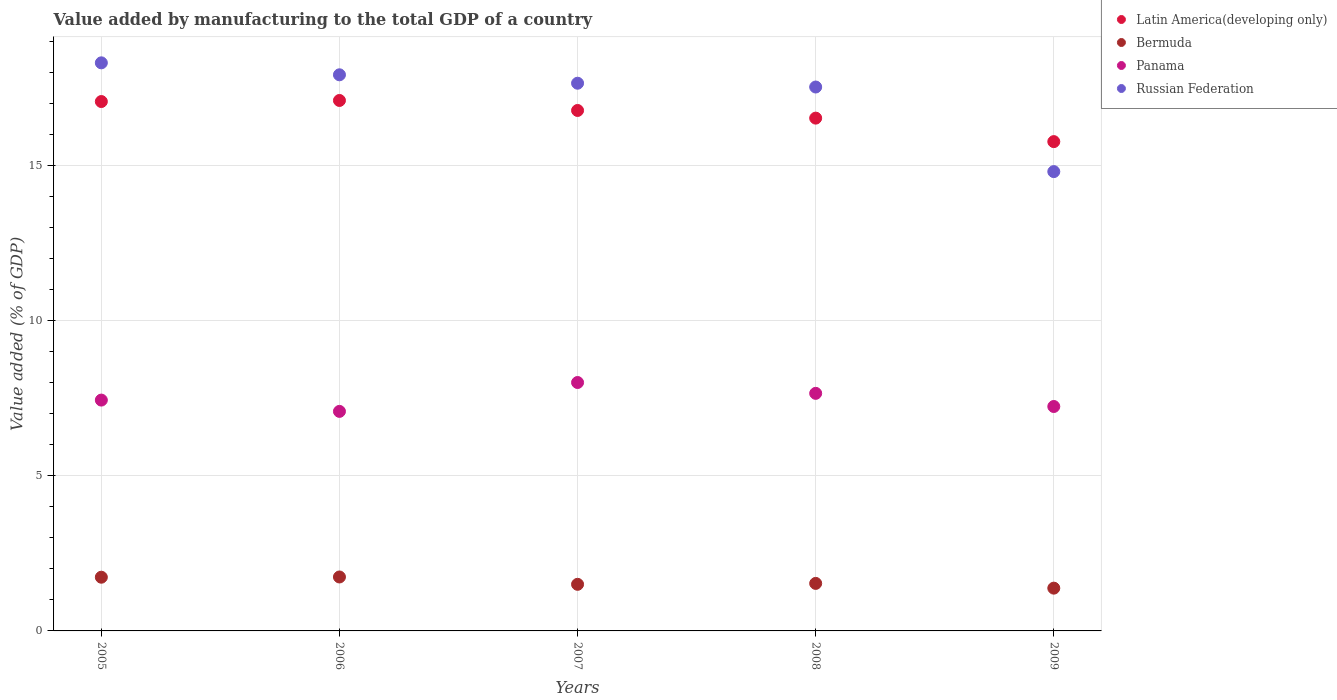Is the number of dotlines equal to the number of legend labels?
Keep it short and to the point. Yes. What is the value added by manufacturing to the total GDP in Latin America(developing only) in 2008?
Keep it short and to the point. 16.52. Across all years, what is the maximum value added by manufacturing to the total GDP in Panama?
Make the answer very short. 8. Across all years, what is the minimum value added by manufacturing to the total GDP in Panama?
Give a very brief answer. 7.07. In which year was the value added by manufacturing to the total GDP in Latin America(developing only) maximum?
Make the answer very short. 2006. In which year was the value added by manufacturing to the total GDP in Panama minimum?
Make the answer very short. 2006. What is the total value added by manufacturing to the total GDP in Panama in the graph?
Keep it short and to the point. 37.39. What is the difference between the value added by manufacturing to the total GDP in Bermuda in 2006 and that in 2008?
Your answer should be very brief. 0.21. What is the difference between the value added by manufacturing to the total GDP in Latin America(developing only) in 2005 and the value added by manufacturing to the total GDP in Russian Federation in 2009?
Ensure brevity in your answer.  2.26. What is the average value added by manufacturing to the total GDP in Latin America(developing only) per year?
Provide a short and direct response. 16.64. In the year 2005, what is the difference between the value added by manufacturing to the total GDP in Panama and value added by manufacturing to the total GDP in Latin America(developing only)?
Make the answer very short. -9.62. What is the ratio of the value added by manufacturing to the total GDP in Latin America(developing only) in 2006 to that in 2007?
Offer a very short reply. 1.02. What is the difference between the highest and the second highest value added by manufacturing to the total GDP in Panama?
Your answer should be very brief. 0.35. What is the difference between the highest and the lowest value added by manufacturing to the total GDP in Panama?
Ensure brevity in your answer.  0.93. Is it the case that in every year, the sum of the value added by manufacturing to the total GDP in Panama and value added by manufacturing to the total GDP in Latin America(developing only)  is greater than the sum of value added by manufacturing to the total GDP in Russian Federation and value added by manufacturing to the total GDP in Bermuda?
Your response must be concise. No. Does the value added by manufacturing to the total GDP in Latin America(developing only) monotonically increase over the years?
Your answer should be compact. No. What is the title of the graph?
Provide a succinct answer. Value added by manufacturing to the total GDP of a country. What is the label or title of the Y-axis?
Ensure brevity in your answer.  Value added (% of GDP). What is the Value added (% of GDP) of Latin America(developing only) in 2005?
Offer a terse response. 17.05. What is the Value added (% of GDP) of Bermuda in 2005?
Your answer should be compact. 1.73. What is the Value added (% of GDP) of Panama in 2005?
Your response must be concise. 7.44. What is the Value added (% of GDP) in Russian Federation in 2005?
Provide a short and direct response. 18.3. What is the Value added (% of GDP) in Latin America(developing only) in 2006?
Your response must be concise. 17.09. What is the Value added (% of GDP) in Bermuda in 2006?
Your answer should be very brief. 1.74. What is the Value added (% of GDP) in Panama in 2006?
Offer a very short reply. 7.07. What is the Value added (% of GDP) in Russian Federation in 2006?
Provide a short and direct response. 17.91. What is the Value added (% of GDP) of Latin America(developing only) in 2007?
Make the answer very short. 16.76. What is the Value added (% of GDP) in Bermuda in 2007?
Give a very brief answer. 1.5. What is the Value added (% of GDP) of Panama in 2007?
Ensure brevity in your answer.  8. What is the Value added (% of GDP) of Russian Federation in 2007?
Give a very brief answer. 17.64. What is the Value added (% of GDP) of Latin America(developing only) in 2008?
Your response must be concise. 16.52. What is the Value added (% of GDP) in Bermuda in 2008?
Give a very brief answer. 1.53. What is the Value added (% of GDP) of Panama in 2008?
Ensure brevity in your answer.  7.65. What is the Value added (% of GDP) of Russian Federation in 2008?
Provide a short and direct response. 17.52. What is the Value added (% of GDP) in Latin America(developing only) in 2009?
Provide a short and direct response. 15.76. What is the Value added (% of GDP) in Bermuda in 2009?
Your answer should be compact. 1.38. What is the Value added (% of GDP) of Panama in 2009?
Make the answer very short. 7.23. What is the Value added (% of GDP) of Russian Federation in 2009?
Provide a succinct answer. 14.79. Across all years, what is the maximum Value added (% of GDP) of Latin America(developing only)?
Your response must be concise. 17.09. Across all years, what is the maximum Value added (% of GDP) of Bermuda?
Your answer should be compact. 1.74. Across all years, what is the maximum Value added (% of GDP) in Panama?
Provide a succinct answer. 8. Across all years, what is the maximum Value added (% of GDP) of Russian Federation?
Your response must be concise. 18.3. Across all years, what is the minimum Value added (% of GDP) of Latin America(developing only)?
Offer a terse response. 15.76. Across all years, what is the minimum Value added (% of GDP) of Bermuda?
Keep it short and to the point. 1.38. Across all years, what is the minimum Value added (% of GDP) of Panama?
Your answer should be compact. 7.07. Across all years, what is the minimum Value added (% of GDP) in Russian Federation?
Your answer should be very brief. 14.79. What is the total Value added (% of GDP) of Latin America(developing only) in the graph?
Make the answer very short. 83.18. What is the total Value added (% of GDP) of Bermuda in the graph?
Your answer should be very brief. 7.88. What is the total Value added (% of GDP) of Panama in the graph?
Your response must be concise. 37.39. What is the total Value added (% of GDP) of Russian Federation in the graph?
Provide a short and direct response. 86.17. What is the difference between the Value added (% of GDP) of Latin America(developing only) in 2005 and that in 2006?
Offer a very short reply. -0.03. What is the difference between the Value added (% of GDP) in Bermuda in 2005 and that in 2006?
Provide a succinct answer. -0.01. What is the difference between the Value added (% of GDP) of Panama in 2005 and that in 2006?
Your response must be concise. 0.36. What is the difference between the Value added (% of GDP) of Russian Federation in 2005 and that in 2006?
Provide a succinct answer. 0.39. What is the difference between the Value added (% of GDP) of Latin America(developing only) in 2005 and that in 2007?
Your answer should be very brief. 0.29. What is the difference between the Value added (% of GDP) in Bermuda in 2005 and that in 2007?
Offer a terse response. 0.23. What is the difference between the Value added (% of GDP) of Panama in 2005 and that in 2007?
Keep it short and to the point. -0.57. What is the difference between the Value added (% of GDP) of Russian Federation in 2005 and that in 2007?
Ensure brevity in your answer.  0.66. What is the difference between the Value added (% of GDP) of Latin America(developing only) in 2005 and that in 2008?
Offer a very short reply. 0.53. What is the difference between the Value added (% of GDP) of Bermuda in 2005 and that in 2008?
Your response must be concise. 0.2. What is the difference between the Value added (% of GDP) in Panama in 2005 and that in 2008?
Provide a short and direct response. -0.22. What is the difference between the Value added (% of GDP) of Russian Federation in 2005 and that in 2008?
Offer a very short reply. 0.78. What is the difference between the Value added (% of GDP) of Latin America(developing only) in 2005 and that in 2009?
Offer a terse response. 1.29. What is the difference between the Value added (% of GDP) of Bermuda in 2005 and that in 2009?
Your answer should be compact. 0.35. What is the difference between the Value added (% of GDP) of Panama in 2005 and that in 2009?
Ensure brevity in your answer.  0.21. What is the difference between the Value added (% of GDP) in Russian Federation in 2005 and that in 2009?
Your response must be concise. 3.5. What is the difference between the Value added (% of GDP) of Latin America(developing only) in 2006 and that in 2007?
Your answer should be compact. 0.32. What is the difference between the Value added (% of GDP) of Bermuda in 2006 and that in 2007?
Give a very brief answer. 0.24. What is the difference between the Value added (% of GDP) of Panama in 2006 and that in 2007?
Give a very brief answer. -0.93. What is the difference between the Value added (% of GDP) in Russian Federation in 2006 and that in 2007?
Your response must be concise. 0.27. What is the difference between the Value added (% of GDP) of Latin America(developing only) in 2006 and that in 2008?
Keep it short and to the point. 0.57. What is the difference between the Value added (% of GDP) in Bermuda in 2006 and that in 2008?
Offer a very short reply. 0.21. What is the difference between the Value added (% of GDP) of Panama in 2006 and that in 2008?
Your answer should be very brief. -0.58. What is the difference between the Value added (% of GDP) in Russian Federation in 2006 and that in 2008?
Offer a terse response. 0.39. What is the difference between the Value added (% of GDP) in Latin America(developing only) in 2006 and that in 2009?
Keep it short and to the point. 1.33. What is the difference between the Value added (% of GDP) of Bermuda in 2006 and that in 2009?
Make the answer very short. 0.36. What is the difference between the Value added (% of GDP) of Panama in 2006 and that in 2009?
Keep it short and to the point. -0.16. What is the difference between the Value added (% of GDP) in Russian Federation in 2006 and that in 2009?
Ensure brevity in your answer.  3.12. What is the difference between the Value added (% of GDP) in Latin America(developing only) in 2007 and that in 2008?
Provide a short and direct response. 0.25. What is the difference between the Value added (% of GDP) in Bermuda in 2007 and that in 2008?
Provide a short and direct response. -0.03. What is the difference between the Value added (% of GDP) of Panama in 2007 and that in 2008?
Keep it short and to the point. 0.35. What is the difference between the Value added (% of GDP) of Russian Federation in 2007 and that in 2008?
Provide a succinct answer. 0.12. What is the difference between the Value added (% of GDP) of Latin America(developing only) in 2007 and that in 2009?
Your answer should be compact. 1. What is the difference between the Value added (% of GDP) in Bermuda in 2007 and that in 2009?
Your response must be concise. 0.12. What is the difference between the Value added (% of GDP) in Panama in 2007 and that in 2009?
Provide a succinct answer. 0.77. What is the difference between the Value added (% of GDP) in Russian Federation in 2007 and that in 2009?
Ensure brevity in your answer.  2.85. What is the difference between the Value added (% of GDP) of Latin America(developing only) in 2008 and that in 2009?
Give a very brief answer. 0.76. What is the difference between the Value added (% of GDP) in Bermuda in 2008 and that in 2009?
Keep it short and to the point. 0.15. What is the difference between the Value added (% of GDP) of Panama in 2008 and that in 2009?
Make the answer very short. 0.42. What is the difference between the Value added (% of GDP) in Russian Federation in 2008 and that in 2009?
Give a very brief answer. 2.72. What is the difference between the Value added (% of GDP) of Latin America(developing only) in 2005 and the Value added (% of GDP) of Bermuda in 2006?
Give a very brief answer. 15.31. What is the difference between the Value added (% of GDP) in Latin America(developing only) in 2005 and the Value added (% of GDP) in Panama in 2006?
Your response must be concise. 9.98. What is the difference between the Value added (% of GDP) of Latin America(developing only) in 2005 and the Value added (% of GDP) of Russian Federation in 2006?
Your response must be concise. -0.86. What is the difference between the Value added (% of GDP) of Bermuda in 2005 and the Value added (% of GDP) of Panama in 2006?
Offer a terse response. -5.34. What is the difference between the Value added (% of GDP) of Bermuda in 2005 and the Value added (% of GDP) of Russian Federation in 2006?
Make the answer very short. -16.18. What is the difference between the Value added (% of GDP) of Panama in 2005 and the Value added (% of GDP) of Russian Federation in 2006?
Make the answer very short. -10.48. What is the difference between the Value added (% of GDP) in Latin America(developing only) in 2005 and the Value added (% of GDP) in Bermuda in 2007?
Offer a terse response. 15.55. What is the difference between the Value added (% of GDP) in Latin America(developing only) in 2005 and the Value added (% of GDP) in Panama in 2007?
Offer a very short reply. 9.05. What is the difference between the Value added (% of GDP) in Latin America(developing only) in 2005 and the Value added (% of GDP) in Russian Federation in 2007?
Offer a very short reply. -0.59. What is the difference between the Value added (% of GDP) in Bermuda in 2005 and the Value added (% of GDP) in Panama in 2007?
Your response must be concise. -6.27. What is the difference between the Value added (% of GDP) of Bermuda in 2005 and the Value added (% of GDP) of Russian Federation in 2007?
Give a very brief answer. -15.91. What is the difference between the Value added (% of GDP) of Panama in 2005 and the Value added (% of GDP) of Russian Federation in 2007?
Give a very brief answer. -10.21. What is the difference between the Value added (% of GDP) in Latin America(developing only) in 2005 and the Value added (% of GDP) in Bermuda in 2008?
Keep it short and to the point. 15.52. What is the difference between the Value added (% of GDP) of Latin America(developing only) in 2005 and the Value added (% of GDP) of Panama in 2008?
Make the answer very short. 9.4. What is the difference between the Value added (% of GDP) in Latin America(developing only) in 2005 and the Value added (% of GDP) in Russian Federation in 2008?
Offer a terse response. -0.47. What is the difference between the Value added (% of GDP) of Bermuda in 2005 and the Value added (% of GDP) of Panama in 2008?
Make the answer very short. -5.92. What is the difference between the Value added (% of GDP) of Bermuda in 2005 and the Value added (% of GDP) of Russian Federation in 2008?
Keep it short and to the point. -15.79. What is the difference between the Value added (% of GDP) in Panama in 2005 and the Value added (% of GDP) in Russian Federation in 2008?
Provide a succinct answer. -10.08. What is the difference between the Value added (% of GDP) in Latin America(developing only) in 2005 and the Value added (% of GDP) in Bermuda in 2009?
Your answer should be compact. 15.67. What is the difference between the Value added (% of GDP) of Latin America(developing only) in 2005 and the Value added (% of GDP) of Panama in 2009?
Offer a terse response. 9.82. What is the difference between the Value added (% of GDP) in Latin America(developing only) in 2005 and the Value added (% of GDP) in Russian Federation in 2009?
Give a very brief answer. 2.26. What is the difference between the Value added (% of GDP) of Bermuda in 2005 and the Value added (% of GDP) of Panama in 2009?
Your answer should be very brief. -5.5. What is the difference between the Value added (% of GDP) in Bermuda in 2005 and the Value added (% of GDP) in Russian Federation in 2009?
Give a very brief answer. -13.07. What is the difference between the Value added (% of GDP) of Panama in 2005 and the Value added (% of GDP) of Russian Federation in 2009?
Give a very brief answer. -7.36. What is the difference between the Value added (% of GDP) in Latin America(developing only) in 2006 and the Value added (% of GDP) in Bermuda in 2007?
Ensure brevity in your answer.  15.59. What is the difference between the Value added (% of GDP) of Latin America(developing only) in 2006 and the Value added (% of GDP) of Panama in 2007?
Ensure brevity in your answer.  9.08. What is the difference between the Value added (% of GDP) in Latin America(developing only) in 2006 and the Value added (% of GDP) in Russian Federation in 2007?
Your answer should be compact. -0.56. What is the difference between the Value added (% of GDP) in Bermuda in 2006 and the Value added (% of GDP) in Panama in 2007?
Make the answer very short. -6.26. What is the difference between the Value added (% of GDP) of Bermuda in 2006 and the Value added (% of GDP) of Russian Federation in 2007?
Offer a terse response. -15.9. What is the difference between the Value added (% of GDP) in Panama in 2006 and the Value added (% of GDP) in Russian Federation in 2007?
Provide a succinct answer. -10.57. What is the difference between the Value added (% of GDP) in Latin America(developing only) in 2006 and the Value added (% of GDP) in Bermuda in 2008?
Offer a terse response. 15.56. What is the difference between the Value added (% of GDP) of Latin America(developing only) in 2006 and the Value added (% of GDP) of Panama in 2008?
Your answer should be very brief. 9.43. What is the difference between the Value added (% of GDP) in Latin America(developing only) in 2006 and the Value added (% of GDP) in Russian Federation in 2008?
Make the answer very short. -0.43. What is the difference between the Value added (% of GDP) in Bermuda in 2006 and the Value added (% of GDP) in Panama in 2008?
Offer a very short reply. -5.91. What is the difference between the Value added (% of GDP) in Bermuda in 2006 and the Value added (% of GDP) in Russian Federation in 2008?
Ensure brevity in your answer.  -15.78. What is the difference between the Value added (% of GDP) of Panama in 2006 and the Value added (% of GDP) of Russian Federation in 2008?
Offer a very short reply. -10.45. What is the difference between the Value added (% of GDP) in Latin America(developing only) in 2006 and the Value added (% of GDP) in Bermuda in 2009?
Your response must be concise. 15.71. What is the difference between the Value added (% of GDP) in Latin America(developing only) in 2006 and the Value added (% of GDP) in Panama in 2009?
Your response must be concise. 9.86. What is the difference between the Value added (% of GDP) in Latin America(developing only) in 2006 and the Value added (% of GDP) in Russian Federation in 2009?
Offer a terse response. 2.29. What is the difference between the Value added (% of GDP) of Bermuda in 2006 and the Value added (% of GDP) of Panama in 2009?
Provide a succinct answer. -5.49. What is the difference between the Value added (% of GDP) in Bermuda in 2006 and the Value added (% of GDP) in Russian Federation in 2009?
Give a very brief answer. -13.06. What is the difference between the Value added (% of GDP) of Panama in 2006 and the Value added (% of GDP) of Russian Federation in 2009?
Ensure brevity in your answer.  -7.72. What is the difference between the Value added (% of GDP) in Latin America(developing only) in 2007 and the Value added (% of GDP) in Bermuda in 2008?
Give a very brief answer. 15.23. What is the difference between the Value added (% of GDP) in Latin America(developing only) in 2007 and the Value added (% of GDP) in Panama in 2008?
Offer a terse response. 9.11. What is the difference between the Value added (% of GDP) in Latin America(developing only) in 2007 and the Value added (% of GDP) in Russian Federation in 2008?
Your response must be concise. -0.76. What is the difference between the Value added (% of GDP) of Bermuda in 2007 and the Value added (% of GDP) of Panama in 2008?
Your response must be concise. -6.15. What is the difference between the Value added (% of GDP) of Bermuda in 2007 and the Value added (% of GDP) of Russian Federation in 2008?
Ensure brevity in your answer.  -16.02. What is the difference between the Value added (% of GDP) of Panama in 2007 and the Value added (% of GDP) of Russian Federation in 2008?
Your answer should be compact. -9.52. What is the difference between the Value added (% of GDP) of Latin America(developing only) in 2007 and the Value added (% of GDP) of Bermuda in 2009?
Your response must be concise. 15.39. What is the difference between the Value added (% of GDP) in Latin America(developing only) in 2007 and the Value added (% of GDP) in Panama in 2009?
Provide a short and direct response. 9.54. What is the difference between the Value added (% of GDP) in Latin America(developing only) in 2007 and the Value added (% of GDP) in Russian Federation in 2009?
Provide a short and direct response. 1.97. What is the difference between the Value added (% of GDP) of Bermuda in 2007 and the Value added (% of GDP) of Panama in 2009?
Your answer should be very brief. -5.73. What is the difference between the Value added (% of GDP) in Bermuda in 2007 and the Value added (% of GDP) in Russian Federation in 2009?
Provide a short and direct response. -13.29. What is the difference between the Value added (% of GDP) in Panama in 2007 and the Value added (% of GDP) in Russian Federation in 2009?
Keep it short and to the point. -6.79. What is the difference between the Value added (% of GDP) of Latin America(developing only) in 2008 and the Value added (% of GDP) of Bermuda in 2009?
Your answer should be compact. 15.14. What is the difference between the Value added (% of GDP) of Latin America(developing only) in 2008 and the Value added (% of GDP) of Panama in 2009?
Your response must be concise. 9.29. What is the difference between the Value added (% of GDP) of Latin America(developing only) in 2008 and the Value added (% of GDP) of Russian Federation in 2009?
Ensure brevity in your answer.  1.72. What is the difference between the Value added (% of GDP) in Bermuda in 2008 and the Value added (% of GDP) in Panama in 2009?
Ensure brevity in your answer.  -5.7. What is the difference between the Value added (% of GDP) in Bermuda in 2008 and the Value added (% of GDP) in Russian Federation in 2009?
Your response must be concise. -13.26. What is the difference between the Value added (% of GDP) of Panama in 2008 and the Value added (% of GDP) of Russian Federation in 2009?
Your answer should be very brief. -7.14. What is the average Value added (% of GDP) of Latin America(developing only) per year?
Give a very brief answer. 16.64. What is the average Value added (% of GDP) in Bermuda per year?
Your answer should be compact. 1.58. What is the average Value added (% of GDP) of Panama per year?
Keep it short and to the point. 7.48. What is the average Value added (% of GDP) in Russian Federation per year?
Offer a very short reply. 17.23. In the year 2005, what is the difference between the Value added (% of GDP) of Latin America(developing only) and Value added (% of GDP) of Bermuda?
Offer a terse response. 15.32. In the year 2005, what is the difference between the Value added (% of GDP) in Latin America(developing only) and Value added (% of GDP) in Panama?
Ensure brevity in your answer.  9.62. In the year 2005, what is the difference between the Value added (% of GDP) of Latin America(developing only) and Value added (% of GDP) of Russian Federation?
Offer a terse response. -1.25. In the year 2005, what is the difference between the Value added (% of GDP) of Bermuda and Value added (% of GDP) of Panama?
Ensure brevity in your answer.  -5.71. In the year 2005, what is the difference between the Value added (% of GDP) in Bermuda and Value added (% of GDP) in Russian Federation?
Make the answer very short. -16.57. In the year 2005, what is the difference between the Value added (% of GDP) of Panama and Value added (% of GDP) of Russian Federation?
Keep it short and to the point. -10.86. In the year 2006, what is the difference between the Value added (% of GDP) of Latin America(developing only) and Value added (% of GDP) of Bermuda?
Give a very brief answer. 15.35. In the year 2006, what is the difference between the Value added (% of GDP) of Latin America(developing only) and Value added (% of GDP) of Panama?
Provide a short and direct response. 10.01. In the year 2006, what is the difference between the Value added (% of GDP) of Latin America(developing only) and Value added (% of GDP) of Russian Federation?
Provide a short and direct response. -0.83. In the year 2006, what is the difference between the Value added (% of GDP) of Bermuda and Value added (% of GDP) of Panama?
Give a very brief answer. -5.33. In the year 2006, what is the difference between the Value added (% of GDP) in Bermuda and Value added (% of GDP) in Russian Federation?
Provide a succinct answer. -16.18. In the year 2006, what is the difference between the Value added (% of GDP) in Panama and Value added (% of GDP) in Russian Federation?
Offer a very short reply. -10.84. In the year 2007, what is the difference between the Value added (% of GDP) of Latin America(developing only) and Value added (% of GDP) of Bermuda?
Your answer should be compact. 15.26. In the year 2007, what is the difference between the Value added (% of GDP) of Latin America(developing only) and Value added (% of GDP) of Panama?
Ensure brevity in your answer.  8.76. In the year 2007, what is the difference between the Value added (% of GDP) of Latin America(developing only) and Value added (% of GDP) of Russian Federation?
Ensure brevity in your answer.  -0.88. In the year 2007, what is the difference between the Value added (% of GDP) of Bermuda and Value added (% of GDP) of Panama?
Your answer should be compact. -6.5. In the year 2007, what is the difference between the Value added (% of GDP) of Bermuda and Value added (% of GDP) of Russian Federation?
Your answer should be compact. -16.14. In the year 2007, what is the difference between the Value added (% of GDP) in Panama and Value added (% of GDP) in Russian Federation?
Ensure brevity in your answer.  -9.64. In the year 2008, what is the difference between the Value added (% of GDP) of Latin America(developing only) and Value added (% of GDP) of Bermuda?
Keep it short and to the point. 14.99. In the year 2008, what is the difference between the Value added (% of GDP) of Latin America(developing only) and Value added (% of GDP) of Panama?
Offer a terse response. 8.87. In the year 2008, what is the difference between the Value added (% of GDP) in Latin America(developing only) and Value added (% of GDP) in Russian Federation?
Your answer should be very brief. -1. In the year 2008, what is the difference between the Value added (% of GDP) in Bermuda and Value added (% of GDP) in Panama?
Ensure brevity in your answer.  -6.12. In the year 2008, what is the difference between the Value added (% of GDP) of Bermuda and Value added (% of GDP) of Russian Federation?
Your answer should be very brief. -15.99. In the year 2008, what is the difference between the Value added (% of GDP) of Panama and Value added (% of GDP) of Russian Federation?
Provide a short and direct response. -9.87. In the year 2009, what is the difference between the Value added (% of GDP) in Latin America(developing only) and Value added (% of GDP) in Bermuda?
Your answer should be very brief. 14.38. In the year 2009, what is the difference between the Value added (% of GDP) in Latin America(developing only) and Value added (% of GDP) in Panama?
Provide a short and direct response. 8.53. In the year 2009, what is the difference between the Value added (% of GDP) in Bermuda and Value added (% of GDP) in Panama?
Ensure brevity in your answer.  -5.85. In the year 2009, what is the difference between the Value added (% of GDP) in Bermuda and Value added (% of GDP) in Russian Federation?
Offer a very short reply. -13.42. In the year 2009, what is the difference between the Value added (% of GDP) of Panama and Value added (% of GDP) of Russian Federation?
Provide a short and direct response. -7.57. What is the ratio of the Value added (% of GDP) of Latin America(developing only) in 2005 to that in 2006?
Your answer should be compact. 1. What is the ratio of the Value added (% of GDP) in Panama in 2005 to that in 2006?
Provide a succinct answer. 1.05. What is the ratio of the Value added (% of GDP) in Russian Federation in 2005 to that in 2006?
Ensure brevity in your answer.  1.02. What is the ratio of the Value added (% of GDP) in Latin America(developing only) in 2005 to that in 2007?
Offer a very short reply. 1.02. What is the ratio of the Value added (% of GDP) in Bermuda in 2005 to that in 2007?
Make the answer very short. 1.15. What is the ratio of the Value added (% of GDP) of Panama in 2005 to that in 2007?
Your answer should be compact. 0.93. What is the ratio of the Value added (% of GDP) of Russian Federation in 2005 to that in 2007?
Offer a very short reply. 1.04. What is the ratio of the Value added (% of GDP) in Latin America(developing only) in 2005 to that in 2008?
Keep it short and to the point. 1.03. What is the ratio of the Value added (% of GDP) in Bermuda in 2005 to that in 2008?
Make the answer very short. 1.13. What is the ratio of the Value added (% of GDP) in Panama in 2005 to that in 2008?
Provide a succinct answer. 0.97. What is the ratio of the Value added (% of GDP) of Russian Federation in 2005 to that in 2008?
Your response must be concise. 1.04. What is the ratio of the Value added (% of GDP) in Latin America(developing only) in 2005 to that in 2009?
Provide a short and direct response. 1.08. What is the ratio of the Value added (% of GDP) in Bermuda in 2005 to that in 2009?
Make the answer very short. 1.26. What is the ratio of the Value added (% of GDP) in Panama in 2005 to that in 2009?
Give a very brief answer. 1.03. What is the ratio of the Value added (% of GDP) of Russian Federation in 2005 to that in 2009?
Offer a terse response. 1.24. What is the ratio of the Value added (% of GDP) of Latin America(developing only) in 2006 to that in 2007?
Your answer should be compact. 1.02. What is the ratio of the Value added (% of GDP) of Bermuda in 2006 to that in 2007?
Offer a terse response. 1.16. What is the ratio of the Value added (% of GDP) of Panama in 2006 to that in 2007?
Keep it short and to the point. 0.88. What is the ratio of the Value added (% of GDP) of Russian Federation in 2006 to that in 2007?
Ensure brevity in your answer.  1.02. What is the ratio of the Value added (% of GDP) in Latin America(developing only) in 2006 to that in 2008?
Give a very brief answer. 1.03. What is the ratio of the Value added (% of GDP) of Bermuda in 2006 to that in 2008?
Make the answer very short. 1.14. What is the ratio of the Value added (% of GDP) of Panama in 2006 to that in 2008?
Your answer should be very brief. 0.92. What is the ratio of the Value added (% of GDP) in Russian Federation in 2006 to that in 2008?
Give a very brief answer. 1.02. What is the ratio of the Value added (% of GDP) of Latin America(developing only) in 2006 to that in 2009?
Your answer should be very brief. 1.08. What is the ratio of the Value added (% of GDP) of Bermuda in 2006 to that in 2009?
Your response must be concise. 1.26. What is the ratio of the Value added (% of GDP) in Panama in 2006 to that in 2009?
Ensure brevity in your answer.  0.98. What is the ratio of the Value added (% of GDP) of Russian Federation in 2006 to that in 2009?
Give a very brief answer. 1.21. What is the ratio of the Value added (% of GDP) in Latin America(developing only) in 2007 to that in 2008?
Offer a terse response. 1.01. What is the ratio of the Value added (% of GDP) in Bermuda in 2007 to that in 2008?
Your answer should be compact. 0.98. What is the ratio of the Value added (% of GDP) in Panama in 2007 to that in 2008?
Offer a terse response. 1.05. What is the ratio of the Value added (% of GDP) of Russian Federation in 2007 to that in 2008?
Offer a terse response. 1.01. What is the ratio of the Value added (% of GDP) of Latin America(developing only) in 2007 to that in 2009?
Your answer should be compact. 1.06. What is the ratio of the Value added (% of GDP) in Bermuda in 2007 to that in 2009?
Provide a succinct answer. 1.09. What is the ratio of the Value added (% of GDP) of Panama in 2007 to that in 2009?
Ensure brevity in your answer.  1.11. What is the ratio of the Value added (% of GDP) of Russian Federation in 2007 to that in 2009?
Ensure brevity in your answer.  1.19. What is the ratio of the Value added (% of GDP) in Latin America(developing only) in 2008 to that in 2009?
Provide a short and direct response. 1.05. What is the ratio of the Value added (% of GDP) of Bermuda in 2008 to that in 2009?
Offer a terse response. 1.11. What is the ratio of the Value added (% of GDP) in Panama in 2008 to that in 2009?
Offer a very short reply. 1.06. What is the ratio of the Value added (% of GDP) in Russian Federation in 2008 to that in 2009?
Ensure brevity in your answer.  1.18. What is the difference between the highest and the second highest Value added (% of GDP) in Latin America(developing only)?
Make the answer very short. 0.03. What is the difference between the highest and the second highest Value added (% of GDP) in Bermuda?
Offer a very short reply. 0.01. What is the difference between the highest and the second highest Value added (% of GDP) in Panama?
Provide a succinct answer. 0.35. What is the difference between the highest and the second highest Value added (% of GDP) of Russian Federation?
Offer a very short reply. 0.39. What is the difference between the highest and the lowest Value added (% of GDP) in Latin America(developing only)?
Make the answer very short. 1.33. What is the difference between the highest and the lowest Value added (% of GDP) of Bermuda?
Ensure brevity in your answer.  0.36. What is the difference between the highest and the lowest Value added (% of GDP) in Panama?
Provide a short and direct response. 0.93. What is the difference between the highest and the lowest Value added (% of GDP) in Russian Federation?
Your answer should be compact. 3.5. 